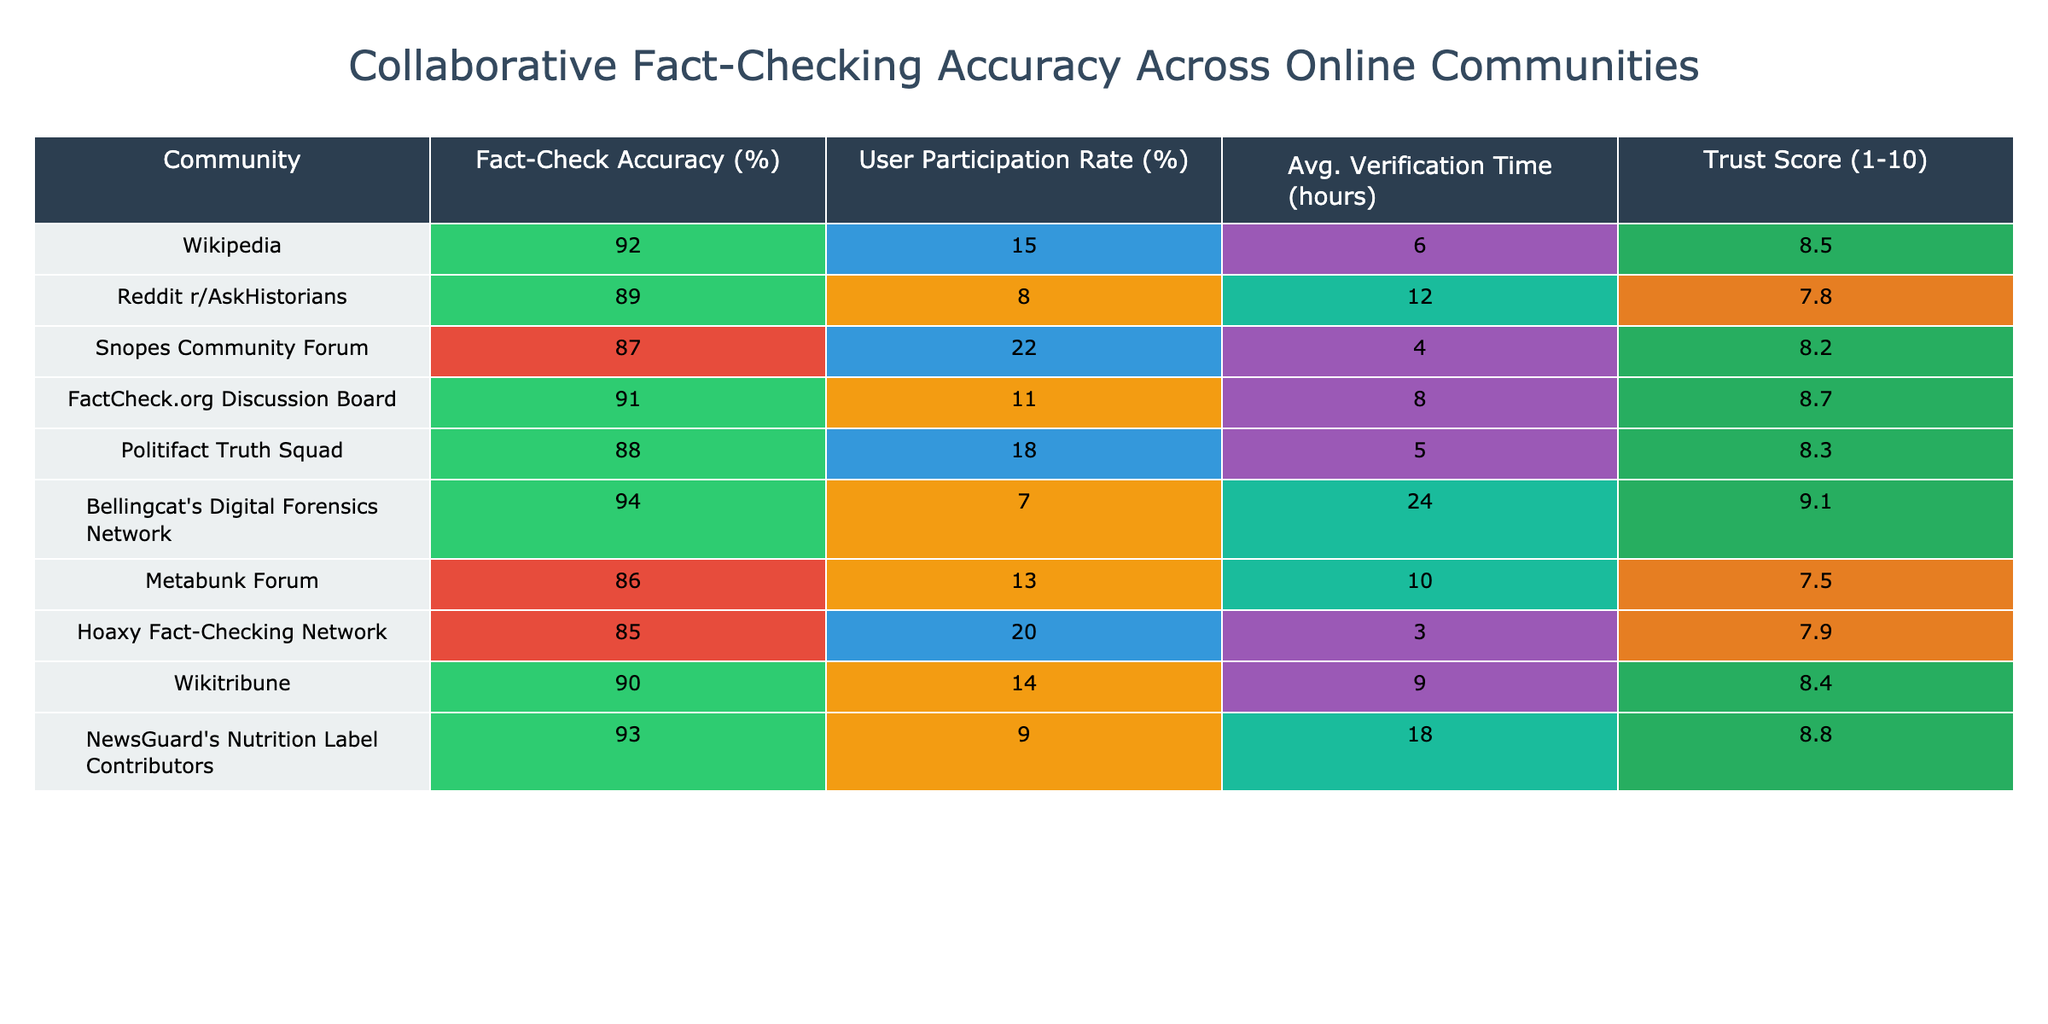What is the fact-check accuracy of Bellingcat's Digital Forensics Network? The table indicates that the fact-check accuracy for Bellingcat's Digital Forensics Network is 94%.
Answer: 94% Which community has the lowest user participation rate? By reviewing the table, Metabunk Forum has the lowest user participation rate at 13%.
Answer: 13% What is the average verification time for FactCheck.org Discussion Board? The verification time listed for FactCheck.org Discussion Board is 8 hours.
Answer: 8 hours Is the trust score for Snopes Community Forum greater than 8? The trust score listed for Snopes Community Forum is 8.2, which is indeed greater than 8.
Answer: Yes Which community has both a high accuracy rate and a high trust score? Bellingcat's Digital Forensics Network has the highest accuracy rate of 94% and a trust score of 9.1, indicating both metrics are high.
Answer: Bellingcat's Digital Forensics Network How does the average verification time of Reddit r/AskHistorians compare to Hoaxy Fact-Checking Network? Reddit r/AskHistorians has an average verification time of 12 hours, while Hoaxy Fact-Checking Network has 3 hours. The difference is 12 - 3 = 9 hours.
Answer: 9 hours Which two communities have an accuracy rate below 88%? The communities with accuracy rates below 88% are Metabunk Forum (86%) and Hoaxy Fact-Checking Network (85%).
Answer: Metabunk Forum and Hoaxy Fact-Checking Network If we sum the user participation rates of all listed communities, what is the total? The user participation rates are 15, 8, 22, 11, 18, 7, 13, 20, 14, and 9. Adding these gives a total of 15 + 8 + 22 + 11 + 18 + 7 + 13 + 20 + 14 + 9 = 137%.
Answer: 137% What community has the highest trust score whereas all others have a score below it? Bellingcat's Digital Forensics Network has the highest trust score of 9.1, with all other communities below this score.
Answer: Bellingcat's Digital Forensics Network What is the average fact-check accuracy rate across all listed communities? Summing the accuracy rates (92 + 89 + 87 + 91 + 88 + 94 + 86 + 85 + 90 + 93) equals 915. Dividing by the number of communities (10), the average accuracy is 91.5%.
Answer: 91.5% 